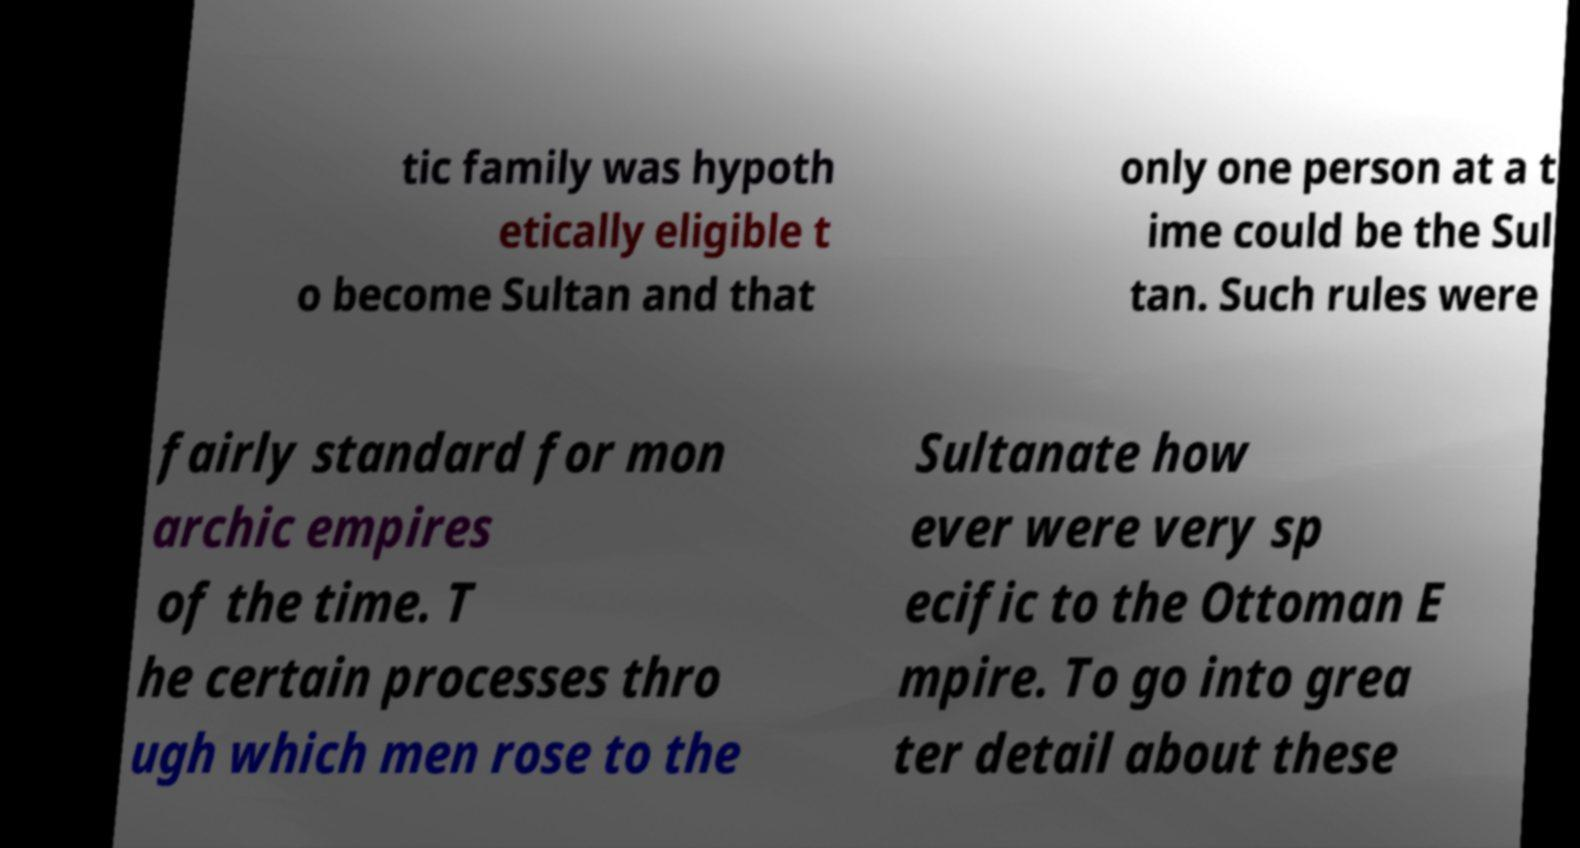There's text embedded in this image that I need extracted. Can you transcribe it verbatim? tic family was hypoth etically eligible t o become Sultan and that only one person at a t ime could be the Sul tan. Such rules were fairly standard for mon archic empires of the time. T he certain processes thro ugh which men rose to the Sultanate how ever were very sp ecific to the Ottoman E mpire. To go into grea ter detail about these 